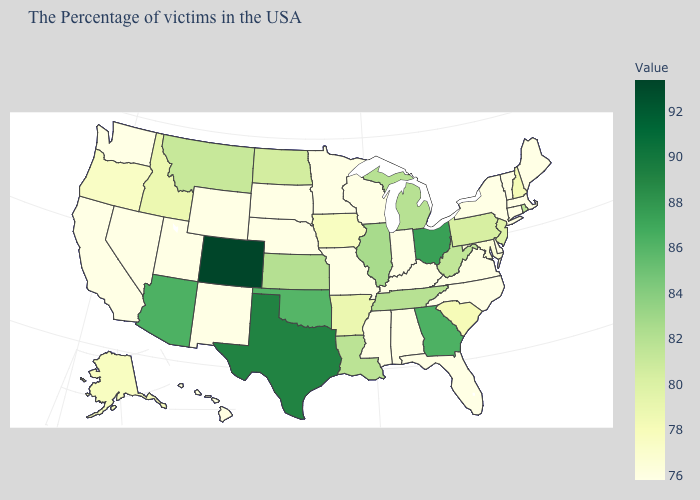Does Maryland have the lowest value in the USA?
Write a very short answer. No. Does Idaho have the lowest value in the USA?
Give a very brief answer. No. Does Arkansas have a lower value than Florida?
Give a very brief answer. No. 